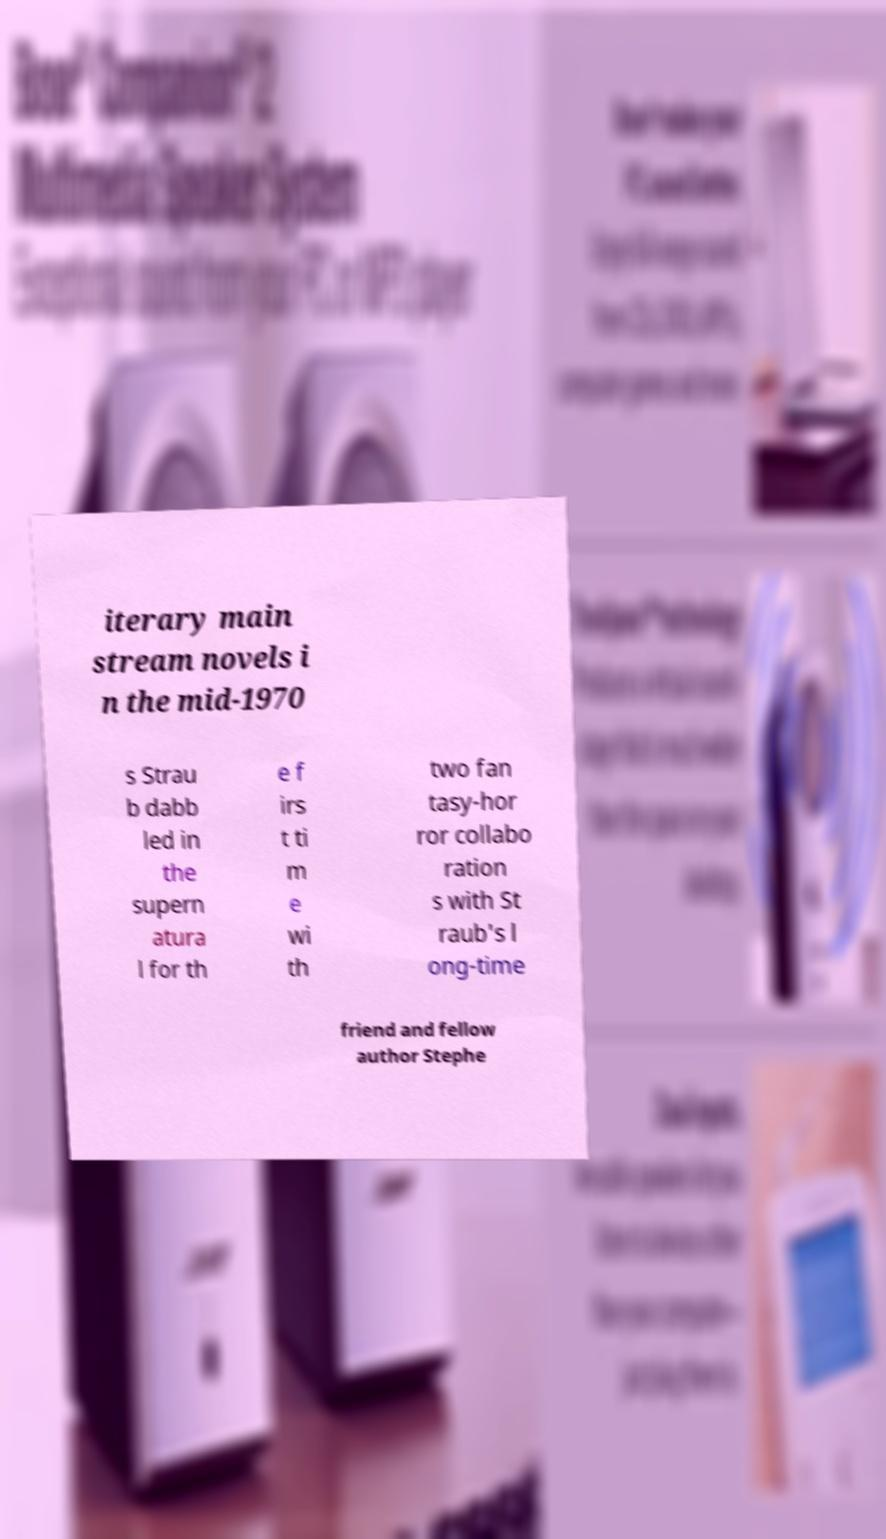There's text embedded in this image that I need extracted. Can you transcribe it verbatim? iterary main stream novels i n the mid-1970 s Strau b dabb led in the supern atura l for th e f irs t ti m e wi th two fan tasy-hor ror collabo ration s with St raub's l ong-time friend and fellow author Stephe 